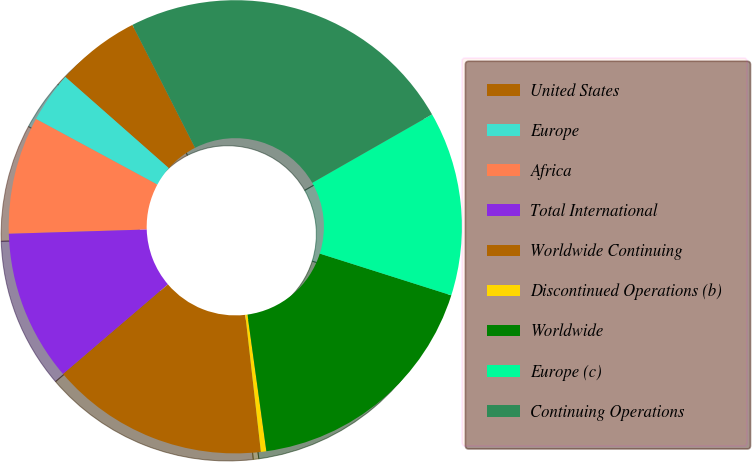Convert chart to OTSL. <chart><loc_0><loc_0><loc_500><loc_500><pie_chart><fcel>United States<fcel>Europe<fcel>Africa<fcel>Total International<fcel>Worldwide Continuing<fcel>Discontinued Operations (b)<fcel>Worldwide<fcel>Europe (c)<fcel>Continuing Operations<nl><fcel>6.0%<fcel>3.61%<fcel>8.38%<fcel>10.77%<fcel>15.54%<fcel>0.39%<fcel>17.92%<fcel>13.15%<fcel>24.24%<nl></chart> 